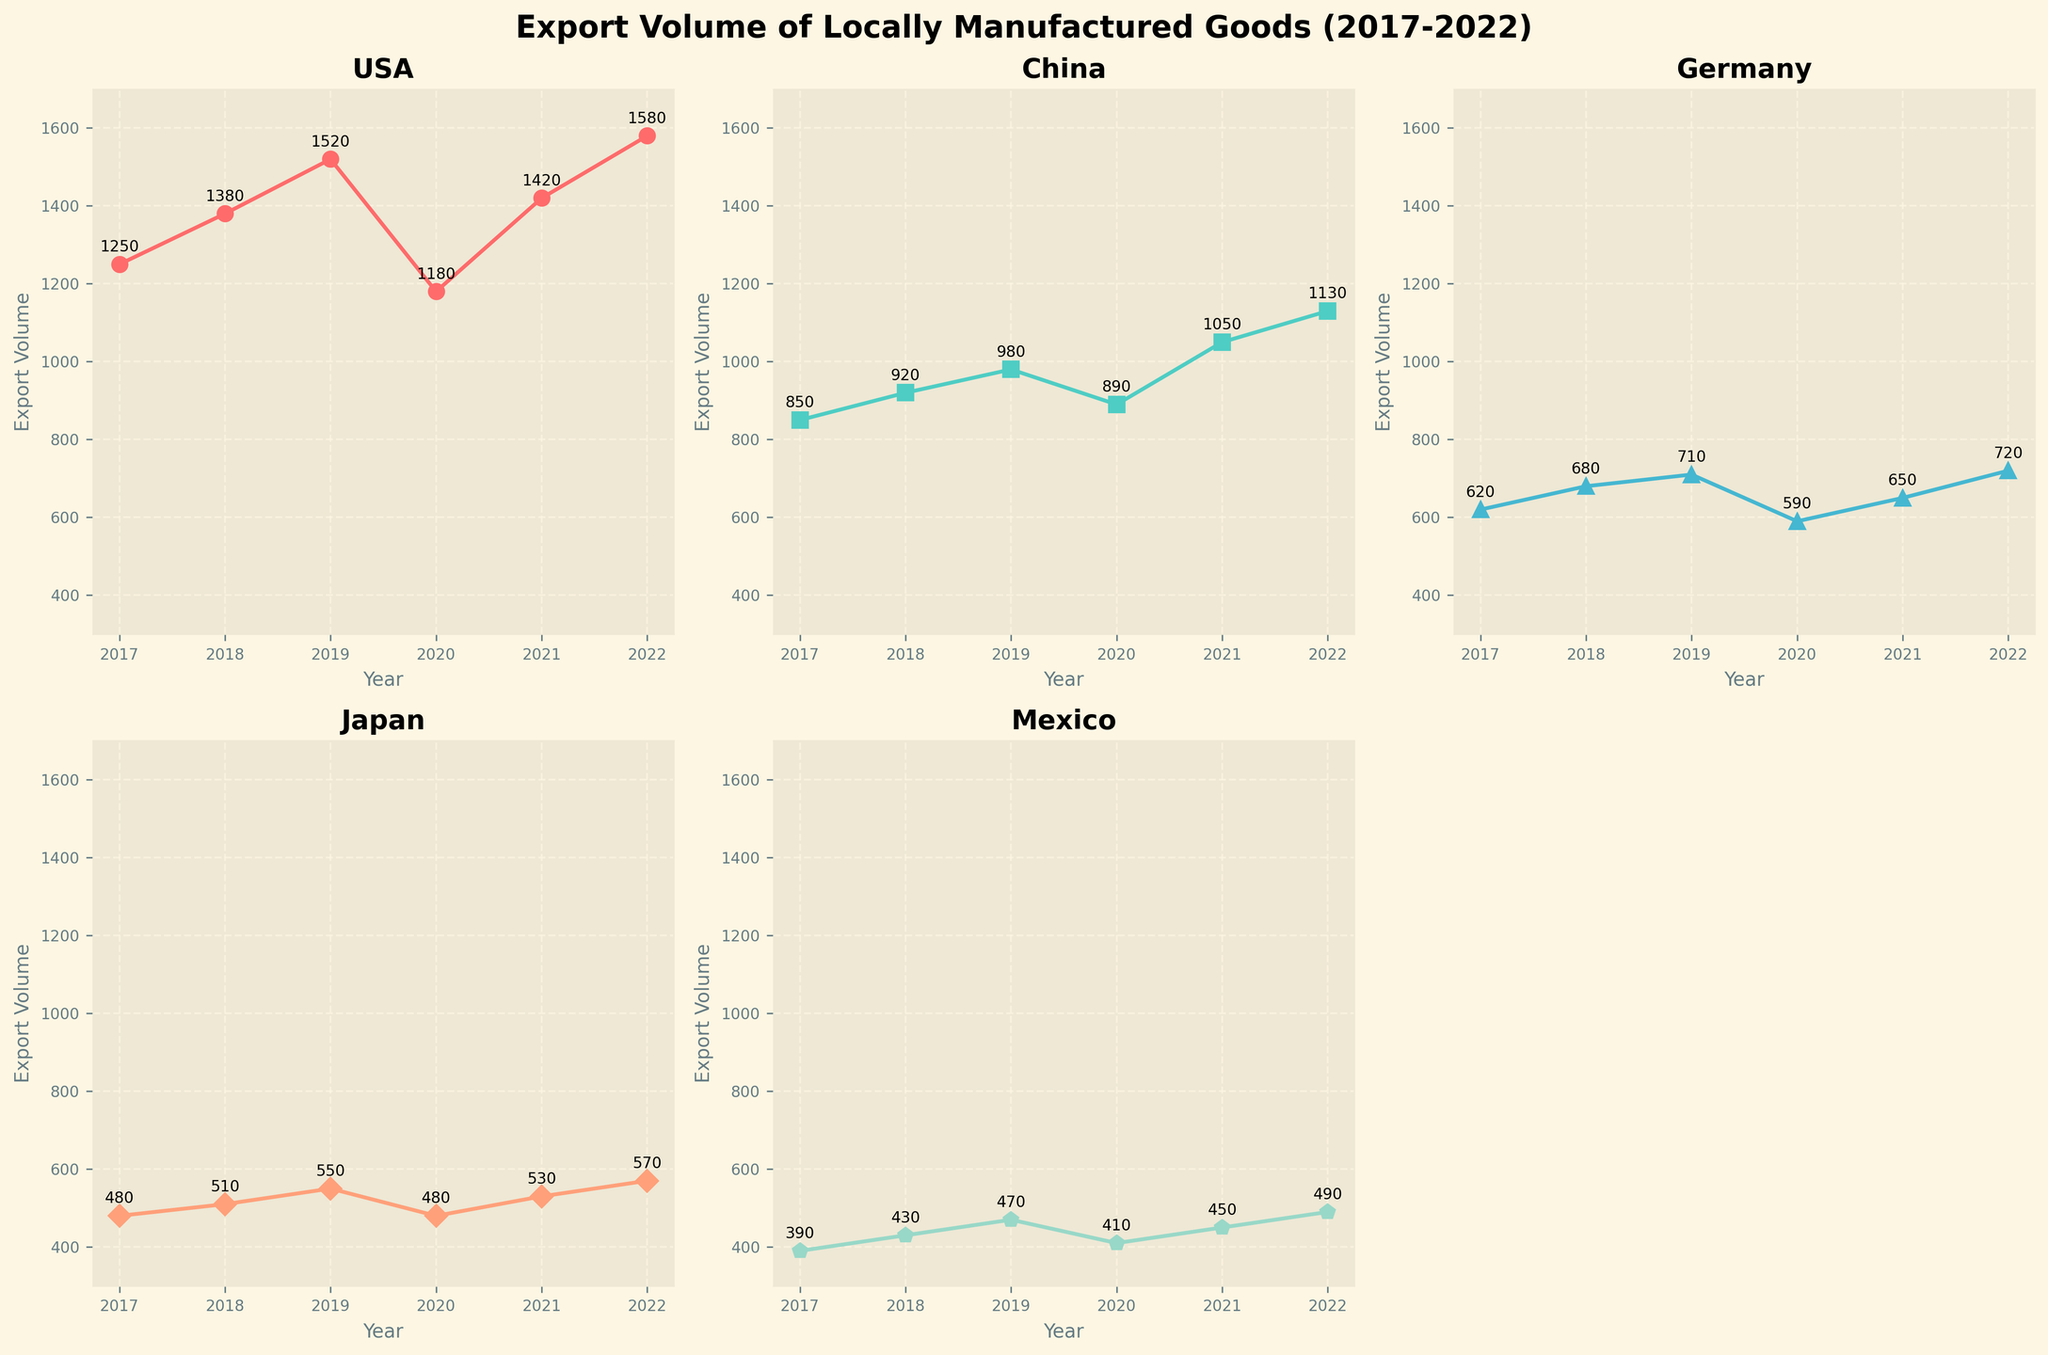Which country had the highest export volume in 2022? Look at the data points for 2022 in each subplot and identify the highest value. China has the highest export volume with 1130 units.
Answer: China Which country saw the largest increase in export volume from 2021 to 2022? Compute the difference between the export volumes of 2022 and 2021 for all countries: USA (160), China (80), Germany (70), Japan (40), and Mexico (40). The USA had the largest increase.
Answer: USA What is the average export volume to Germany from 2017 to 2022? Sum the export volumes to Germany over the given years and divide by the number of years: (620 + 680 + 710 + 590 + 650 + 720) / 6 = 661.67
Answer: 661.67 How many countries have export volumes that exceeded 1000 units in 2020? Examine the 2020 data points in each subplot and count the number of countries with values exceeding 1000: only USA.
Answer: 1 What is the trend of export volumes to China over the years? Observe the plot for China and analyze the general pattern: the export volume starts at 850 in 2017 and generally increases each year, with a slight decrease in 2020, then continues to rise.
Answer: Increasing with a dip in 2020 In which year did Japan have the lowest export volume? Identify the lowest data point in the Japan subplot. The year with the lowest export volume is 2017 with 480 units.
Answer: 2017 Which country experienced the greatest year-to-year fluctuation in export volumes? Calculate the year-to-year difference for each country, then find the largest fluctuation: USA (130, 140, -340, 240, 160), China (70, 60, -90, 160, 80), Germany (60, 30, -120, 60, 70), Japan (30, 40, -70, 50, 40), Mexico (40, 40, -60, 40, 40). The USA exhibits the greatest fluctuation.
Answer: USA Comparing 2018 and 2021, which country had a larger growth in export volume to Germany? Compute the increase in export volume for Germany between 2018 and 2021: 2021 volume (650) - 2018 volume (680) = -30, indicating a decrease rather than growth.
Answer: Decrease of -30 Which subplot has the lowest export volume in 2019? Locate and compare the 2019 data points across all subplots and identify the lowest one: Mexico with 470 units.
Answer: Mexico 